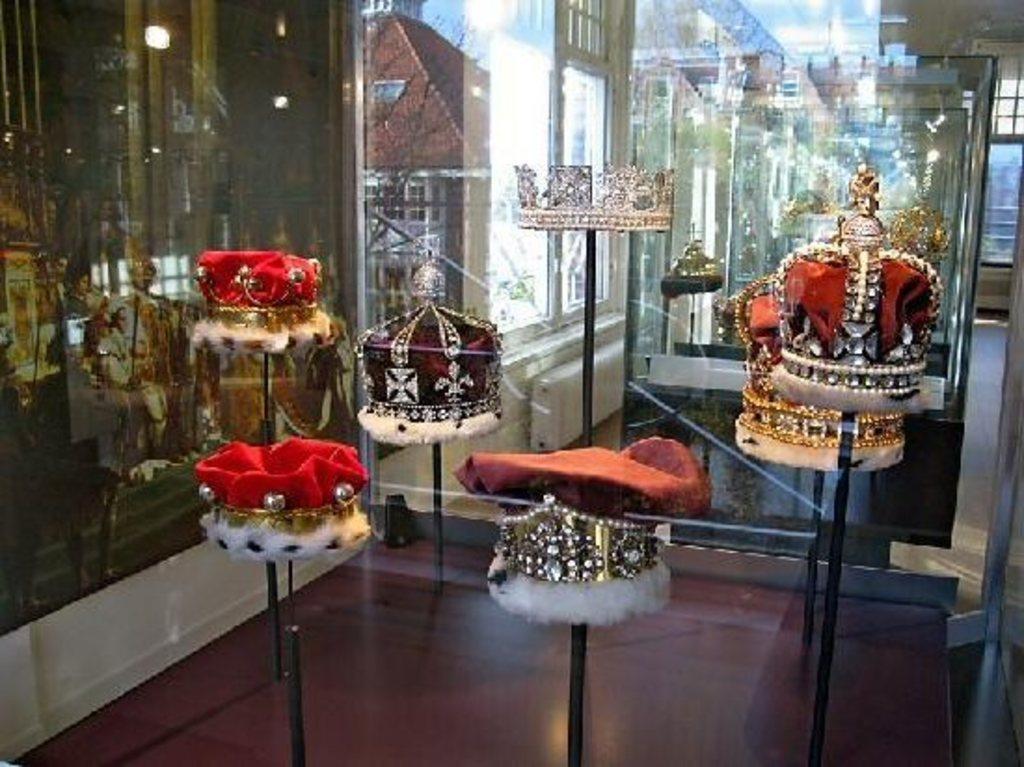Could you give a brief overview of what you see in this image? In this picture in the front there are hats on the poles. In the background there is glass and on the glass there are reflections. 